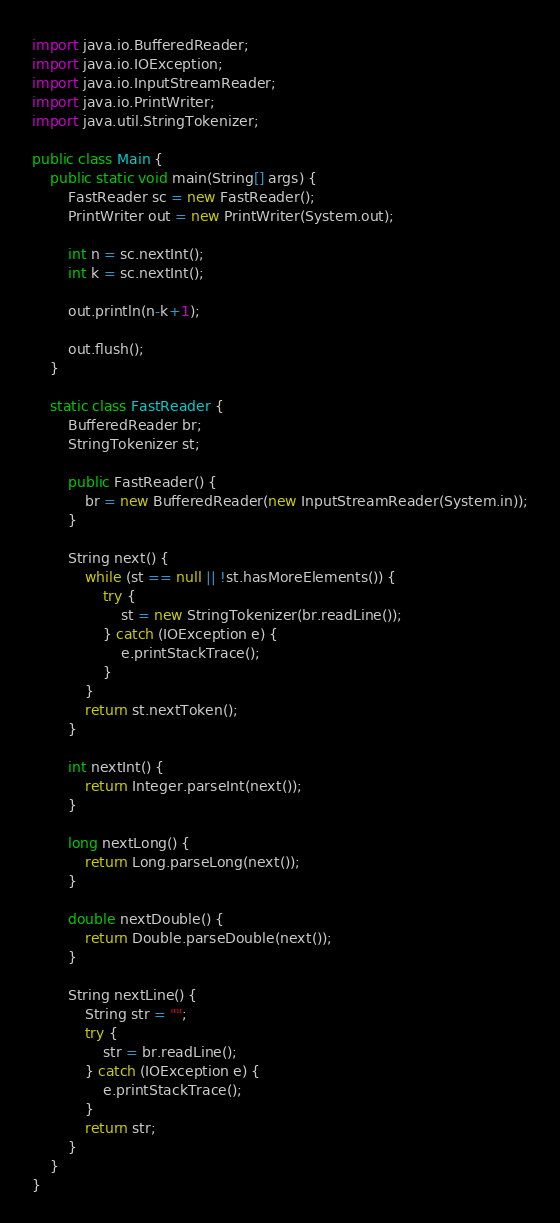Convert code to text. <code><loc_0><loc_0><loc_500><loc_500><_Java_>
import java.io.BufferedReader;
import java.io.IOException;
import java.io.InputStreamReader;
import java.io.PrintWriter;
import java.util.StringTokenizer;

public class Main {
    public static void main(String[] args) {
        FastReader sc = new FastReader();
        PrintWriter out = new PrintWriter(System.out);

        int n = sc.nextInt();
        int k = sc.nextInt();

        out.println(n-k+1);

        out.flush();
    }

    static class FastReader {
        BufferedReader br;
        StringTokenizer st;

        public FastReader() {
            br = new BufferedReader(new InputStreamReader(System.in));
        }

        String next() {
            while (st == null || !st.hasMoreElements()) {
                try {
                    st = new StringTokenizer(br.readLine());
                } catch (IOException e) {
                    e.printStackTrace();
                }
            }
            return st.nextToken();
        }

        int nextInt() {
            return Integer.parseInt(next());
        }

        long nextLong() {
            return Long.parseLong(next());
        }

        double nextDouble() {
            return Double.parseDouble(next());
        }

        String nextLine() {
            String str = "";
            try {
                str = br.readLine();
            } catch (IOException e) {
                e.printStackTrace();
            }
            return str;
        }
    }
}</code> 